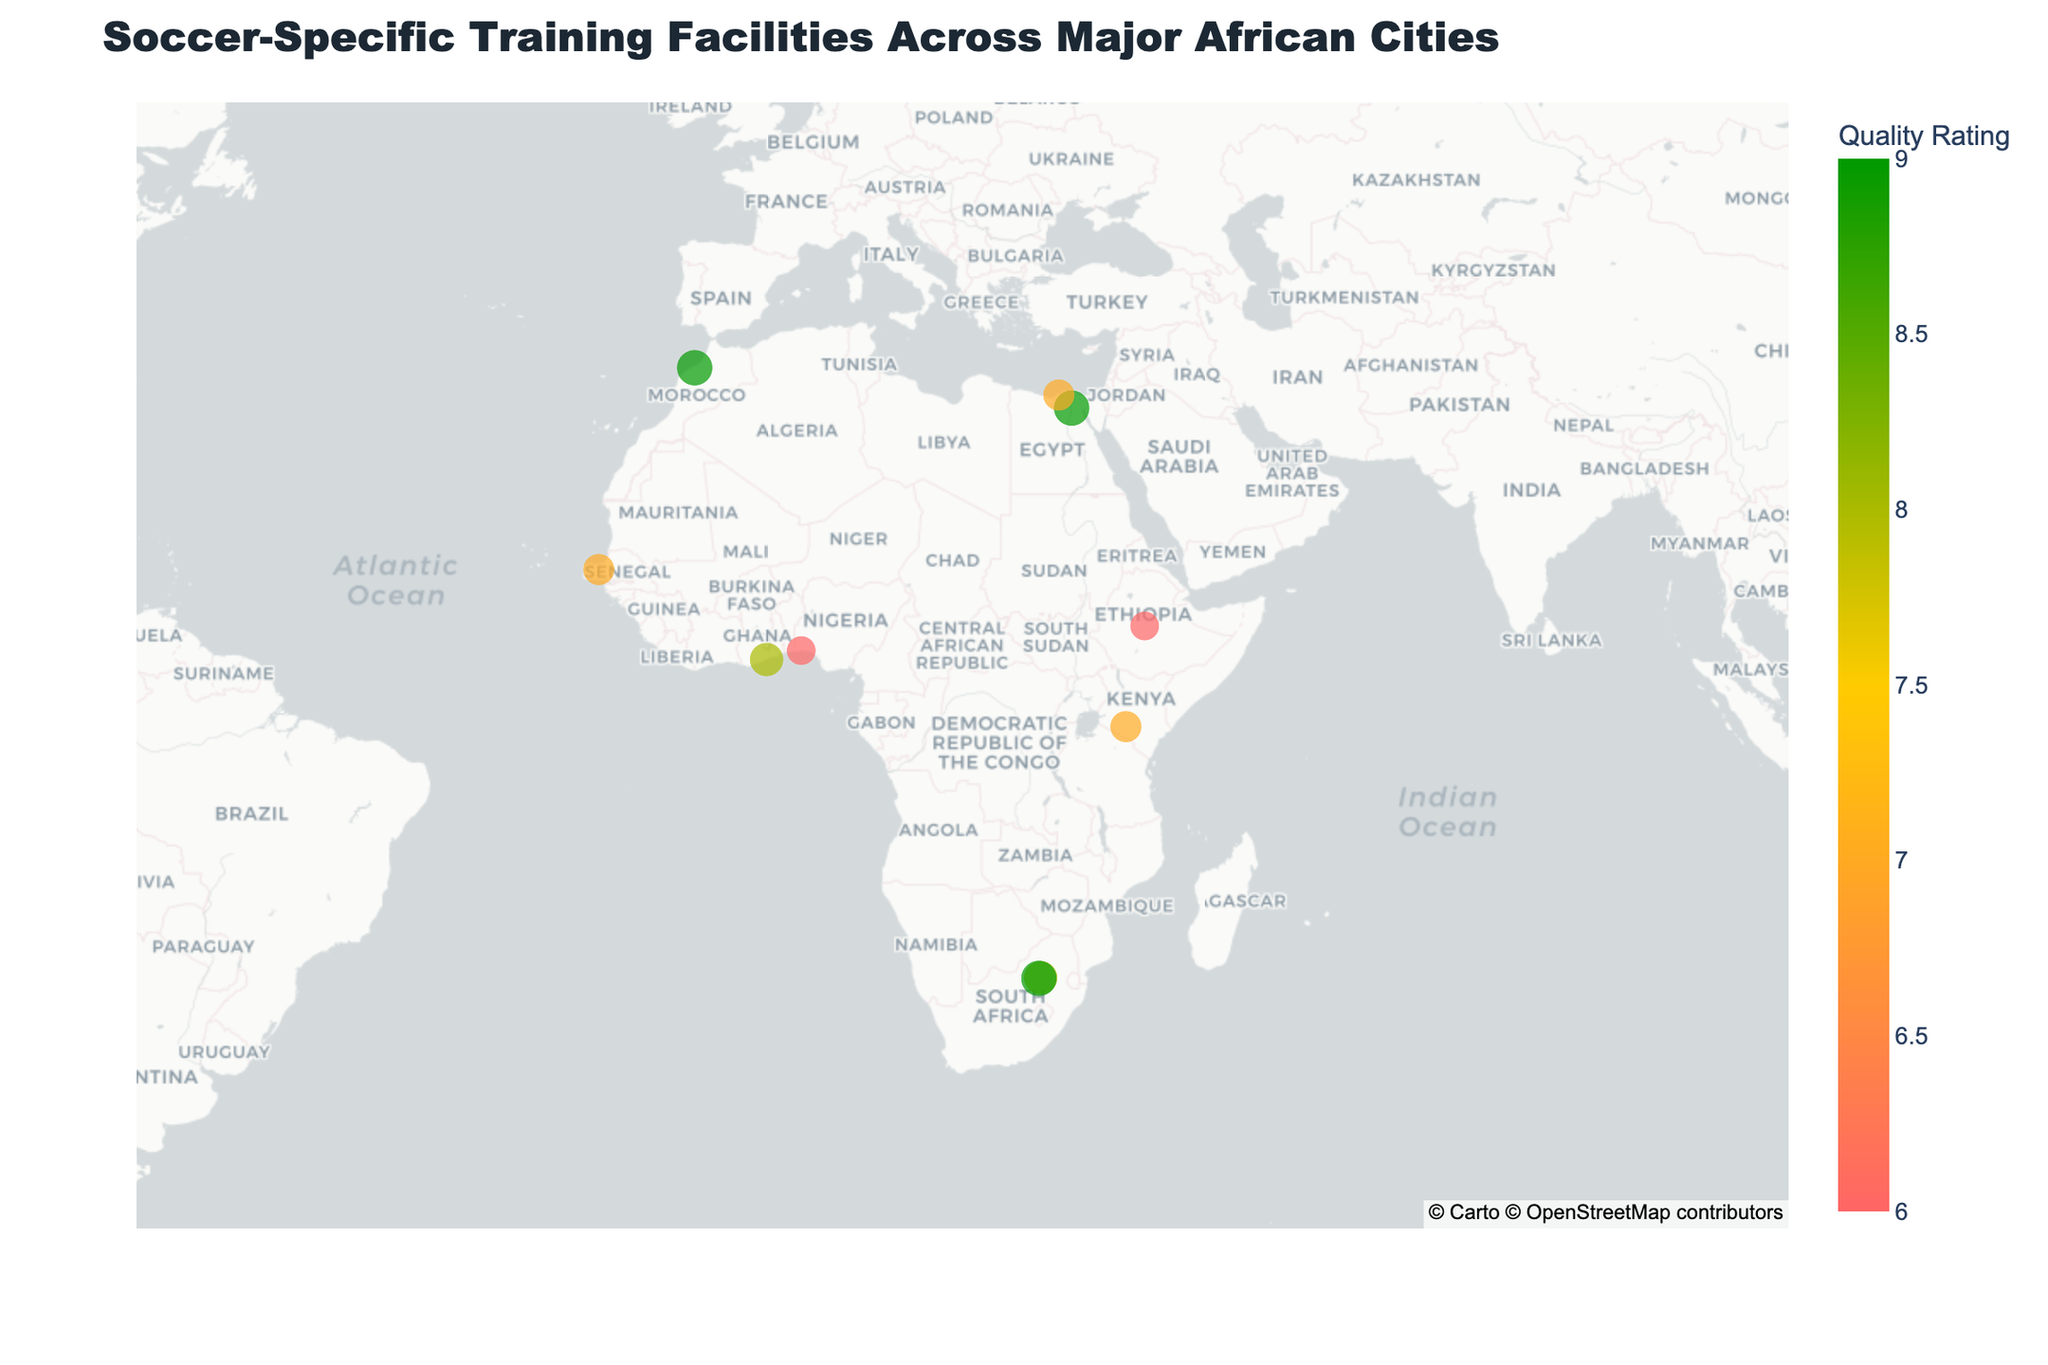What is the title of the map? The title of the map is usually placed at the top center of the figure. Observing the top of the figure, you can see the title reads "Soccer-Specific Training Facilities Across Major African Cities".
Answer: Soccer-Specific Training Facilities Across Major African Cities How many cities have soccer-specific training facilities shown on the map? Count the number of unique data points (cities) displayed on the map, each represented by a marker. From the given data and observing the figure, there are a total of 10 cities.
Answer: 10 Which city has the highest quality rating for its soccer-specific training facility? Check the hover information and markers to identify the city with the highest quality rating. Johannesburg, Cairo, and Soweto have the highest quality ratings of 9.
Answer: Johannesburg, Cairo, Soweto Are there any cities with a quality rating of 6? If so, name them. Look for markers representing facilities with a quality rating of 6. Hovering over these markers, Lagos and Addis Ababa are identified as the cities with a rating of 6.
Answer: Lagos, Addis Ababa How are the cities with specialized equipment indicated on the map? Hover over markers to check the specialized equipment attribute. Cities with "Yes" in the Specialized Equipment field have different marker sizes corresponding to their quality ratings. From the map's hover tool, these cities include Johannesburg, Cairo, Lagos, Accra, Casablanca, Soweto, and Alexandria.
Answer: Bigger marker size and positive hover data Which city has the lowest latitude among those with ratings of at least 7? Focus on cities with at least a 7 quality rating and compare their latitudes. The city with the lowest latitude is Johannesburg, with a latitude of -26.2041.
Answer: Johannesburg Compare the quality ratings between Accra and Cairo. Which one is higher? Identify Accra and Cairo on the map and compare their quality ratings. Accra has a quality rating of 8, whereas Cairo has a rating of 9, making Cairo's rating higher.
Answer: Cairo Calculate the average quality rating of the training facilities across all cities. Sum the quality ratings for all 10 cities and divide by the number of cities. From the provided data: (8+9+7+6+8+9+7+6+9+7)/10 = 76/10 = 7.6
Answer: 7.6 Which city in South Africa, listed, has a training facility with a higher quality rating? There are two cities: Johannesburg and Soweto. Compare their quality ratings. Both have a rating of 9.
Answer: Both are equal (9) Are there more cities using specialized equipment than those that do not? Categorize the cities by their specialized equipment attribute and count. From the data: seven cities have specialized equipment ("Yes"), and three do not ("No"); so there are more cities that use specialized equipment.
Answer: Yes 